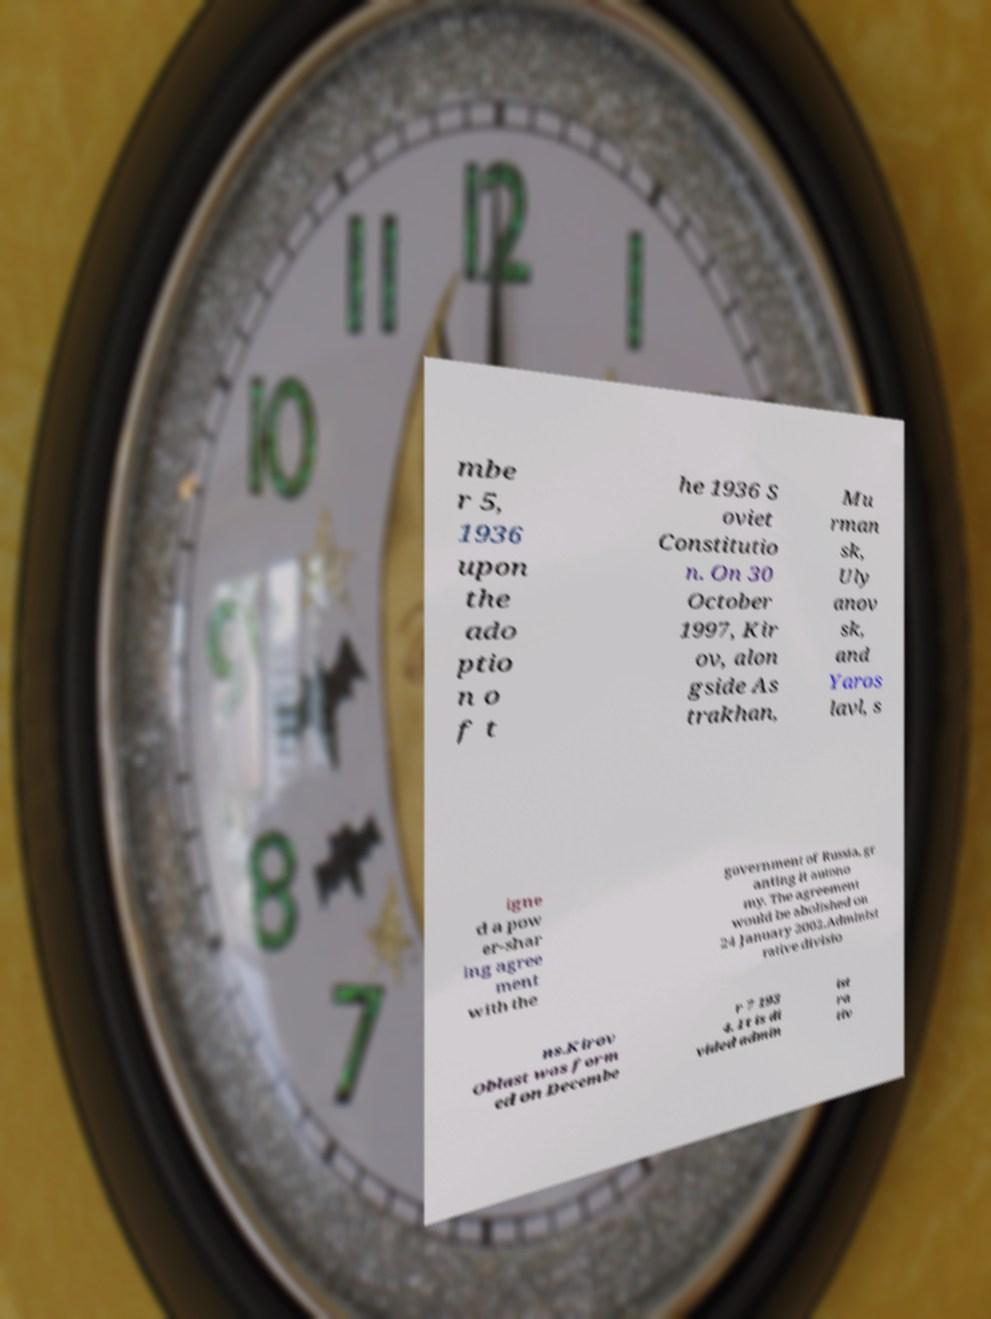There's text embedded in this image that I need extracted. Can you transcribe it verbatim? mbe r 5, 1936 upon the ado ptio n o f t he 1936 S oviet Constitutio n. On 30 October 1997, Kir ov, alon gside As trakhan, Mu rman sk, Uly anov sk, and Yaros lavl, s igne d a pow er-shar ing agree ment with the government of Russia, gr anting it autono my. The agreement would be abolished on 24 January 2002.Administ rative divisio ns.Kirov Oblast was form ed on Decembe r 7 193 4. It is di vided admin ist ra tiv 